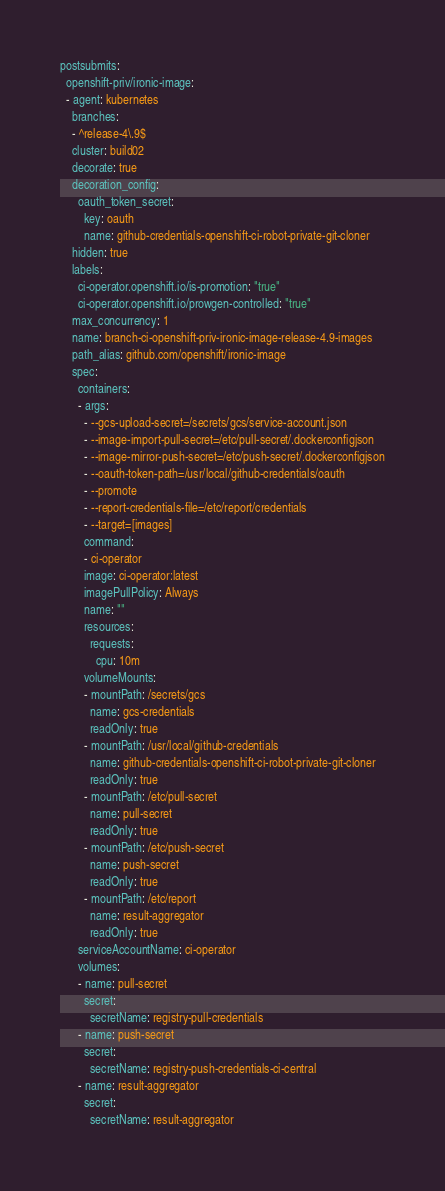<code> <loc_0><loc_0><loc_500><loc_500><_YAML_>postsubmits:
  openshift-priv/ironic-image:
  - agent: kubernetes
    branches:
    - ^release-4\.9$
    cluster: build02
    decorate: true
    decoration_config:
      oauth_token_secret:
        key: oauth
        name: github-credentials-openshift-ci-robot-private-git-cloner
    hidden: true
    labels:
      ci-operator.openshift.io/is-promotion: "true"
      ci-operator.openshift.io/prowgen-controlled: "true"
    max_concurrency: 1
    name: branch-ci-openshift-priv-ironic-image-release-4.9-images
    path_alias: github.com/openshift/ironic-image
    spec:
      containers:
      - args:
        - --gcs-upload-secret=/secrets/gcs/service-account.json
        - --image-import-pull-secret=/etc/pull-secret/.dockerconfigjson
        - --image-mirror-push-secret=/etc/push-secret/.dockerconfigjson
        - --oauth-token-path=/usr/local/github-credentials/oauth
        - --promote
        - --report-credentials-file=/etc/report/credentials
        - --target=[images]
        command:
        - ci-operator
        image: ci-operator:latest
        imagePullPolicy: Always
        name: ""
        resources:
          requests:
            cpu: 10m
        volumeMounts:
        - mountPath: /secrets/gcs
          name: gcs-credentials
          readOnly: true
        - mountPath: /usr/local/github-credentials
          name: github-credentials-openshift-ci-robot-private-git-cloner
          readOnly: true
        - mountPath: /etc/pull-secret
          name: pull-secret
          readOnly: true
        - mountPath: /etc/push-secret
          name: push-secret
          readOnly: true
        - mountPath: /etc/report
          name: result-aggregator
          readOnly: true
      serviceAccountName: ci-operator
      volumes:
      - name: pull-secret
        secret:
          secretName: registry-pull-credentials
      - name: push-secret
        secret:
          secretName: registry-push-credentials-ci-central
      - name: result-aggregator
        secret:
          secretName: result-aggregator
</code> 